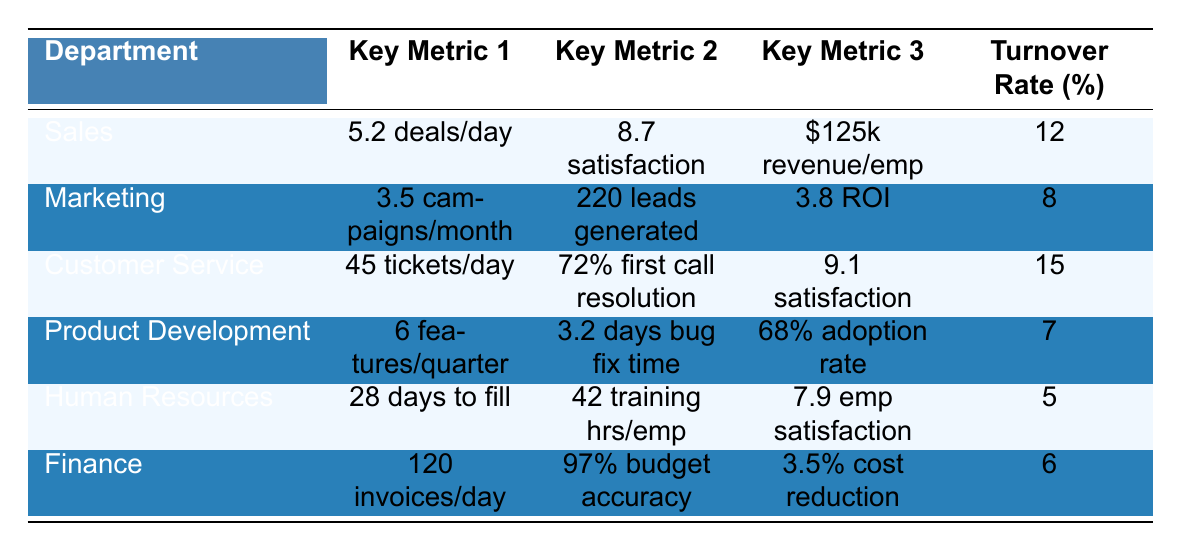What is the employee turnover rate in the Finance department? In the table, the turnover rate for each department is listed in the last column. For the Finance department, it shows 6% as the turnover rate.
Answer: 6% Which department has the highest customer satisfaction score? The customer satisfaction scores are present for the Sales and Customer Service departments in the third column. Sales has a score of 8.7, while Customer Service has a score of 9.1. Comparing these values, Customer Service has the highest score of 9.1.
Answer: Customer Service What is the average employee turnover rate for all departments? To calculate the average turnover rate, sum the turnover rates for all departments (12 + 8 + 15 + 7 + 5 + 6 = 53), then divide by the number of departments (6). Thus, the average turnover rate is 53 / 6 = 8.83%.
Answer: 8.83% Is the bug fix time average for Product Development less than 4 days? The table shows that the bug fix time average for Product Development is 3.2 days. Since 3.2 is indeed less than 4, the statement is true.
Answer: Yes Which departments have an employee turnover rate lower than 10%? The turnover rates for all departments are 12, 8, 15, 7, 5, and 6 respectively. The departments with rates lower than 10% are Marketing (8%), Product Development (7%), Human Resources (5%), and Finance (6%). Thus, four departments meet this criterion.
Answer: 4 departments What is the total number of deals converted daily by the Sales and Customer Service departments combined? The average daily deals for Sales is 5.2, and the average tickets resolved daily in Customer Service is irrelevant. However, to find just the deals for Sales, since Customer Service doesn’t deal with conversions, the total number of deals is solely from Sales, which is 5.2 daily.
Answer: 5.2 Which department processes more invoices daily, Finance or Customer Service? The table indicates that Finance processes 120 invoices daily, whereas Customer Service resolves 45 tickets daily. Comparing the two values, Finance clearly processes more invoices than Customer Service.
Answer: Finance What is the marketing ROI for the Marketing department? The marketing ROI is listed in the table under the Marketing department's key metrics, where it shows a figure of 3.8.
Answer: 3.8 Does the Human Resources department have the highest employee satisfaction score? The employee satisfaction score for Human Resources is 7.9. Comparing this score with the customer satisfaction scores of Sales (8.7) and Customer Service (9.1), Human Resources does not have the highest score.
Answer: No If the average number of tickets resolved daily in Customer Service increases by 10%, what will the new figure be? The current average tickets resolved daily in Customer Service is 45. A 10% increase means we calculate 45 * 10% = 4.5. Therefore, the new figure would be 45 + 4.5 = 49.5 tickets daily.
Answer: 49.5 tickets 